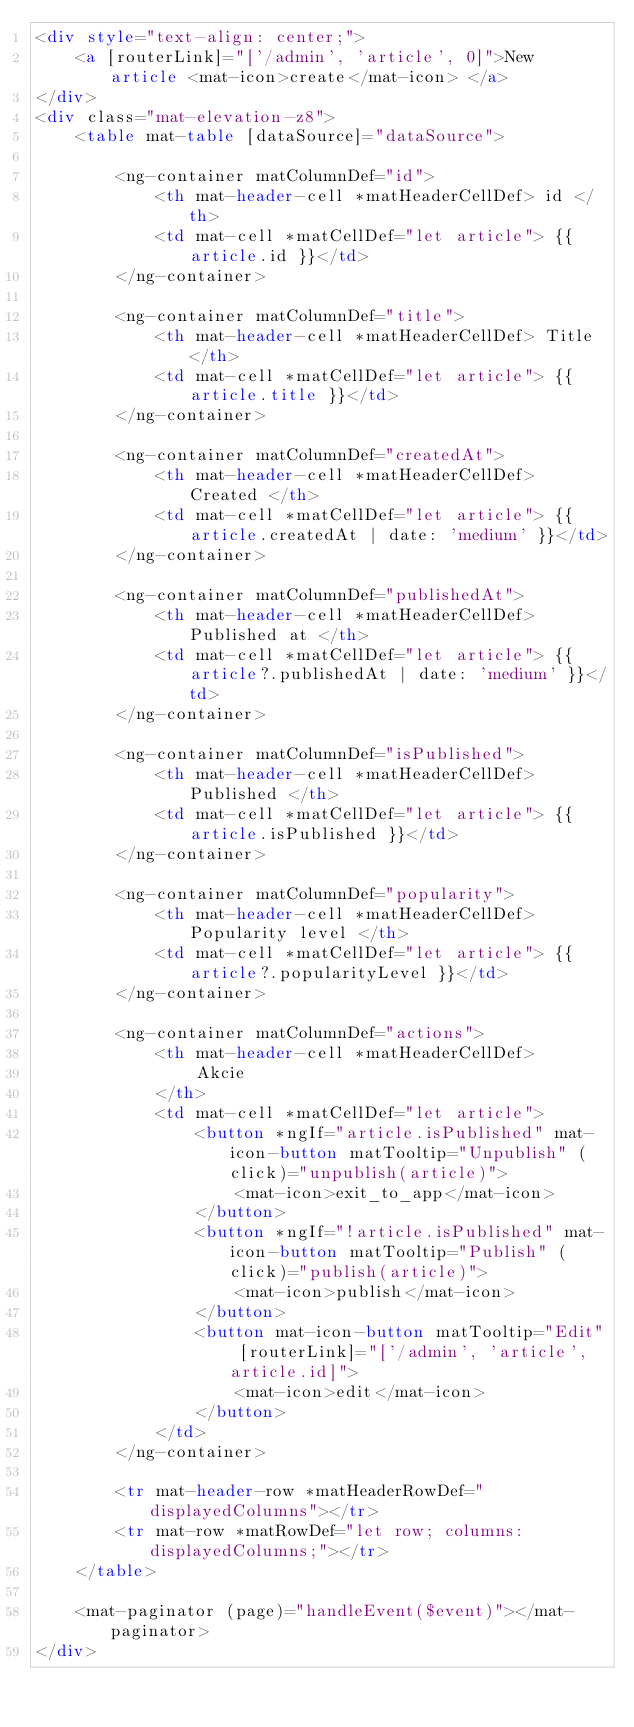<code> <loc_0><loc_0><loc_500><loc_500><_HTML_><div style="text-align: center;">
    <a [routerLink]="['/admin', 'article', 0]">New article <mat-icon>create</mat-icon> </a>
</div>
<div class="mat-elevation-z8">
    <table mat-table [dataSource]="dataSource">

        <ng-container matColumnDef="id">
            <th mat-header-cell *matHeaderCellDef> id </th>
            <td mat-cell *matCellDef="let article"> {{ article.id }}</td>
        </ng-container>

        <ng-container matColumnDef="title">
            <th mat-header-cell *matHeaderCellDef> Title </th>
            <td mat-cell *matCellDef="let article"> {{ article.title }}</td>
        </ng-container>

        <ng-container matColumnDef="createdAt">
            <th mat-header-cell *matHeaderCellDef> Created </th>
            <td mat-cell *matCellDef="let article"> {{ article.createdAt | date: 'medium' }}</td>
        </ng-container>

        <ng-container matColumnDef="publishedAt">
            <th mat-header-cell *matHeaderCellDef> Published at </th>
            <td mat-cell *matCellDef="let article"> {{ article?.publishedAt | date: 'medium' }}</td>
        </ng-container>

        <ng-container matColumnDef="isPublished">
            <th mat-header-cell *matHeaderCellDef> Published </th>
            <td mat-cell *matCellDef="let article"> {{ article.isPublished }}</td>
        </ng-container>

        <ng-container matColumnDef="popularity">
            <th mat-header-cell *matHeaderCellDef> Popularity level </th>
            <td mat-cell *matCellDef="let article"> {{ article?.popularityLevel }}</td>
        </ng-container>

        <ng-container matColumnDef="actions">
            <th mat-header-cell *matHeaderCellDef>
                Akcie
            </th>
            <td mat-cell *matCellDef="let article">
                <button *ngIf="article.isPublished" mat-icon-button matTooltip="Unpublish" (click)="unpublish(article)">
                    <mat-icon>exit_to_app</mat-icon>
                </button>
                <button *ngIf="!article.isPublished" mat-icon-button matTooltip="Publish" (click)="publish(article)">
                    <mat-icon>publish</mat-icon>
                </button>
                <button mat-icon-button matTooltip="Edit" [routerLink]="['/admin', 'article', article.id]">
                    <mat-icon>edit</mat-icon>
                </button>
            </td>
        </ng-container>

        <tr mat-header-row *matHeaderRowDef="displayedColumns"></tr>
        <tr mat-row *matRowDef="let row; columns: displayedColumns;"></tr>
    </table>

    <mat-paginator (page)="handleEvent($event)"></mat-paginator>
</div></code> 